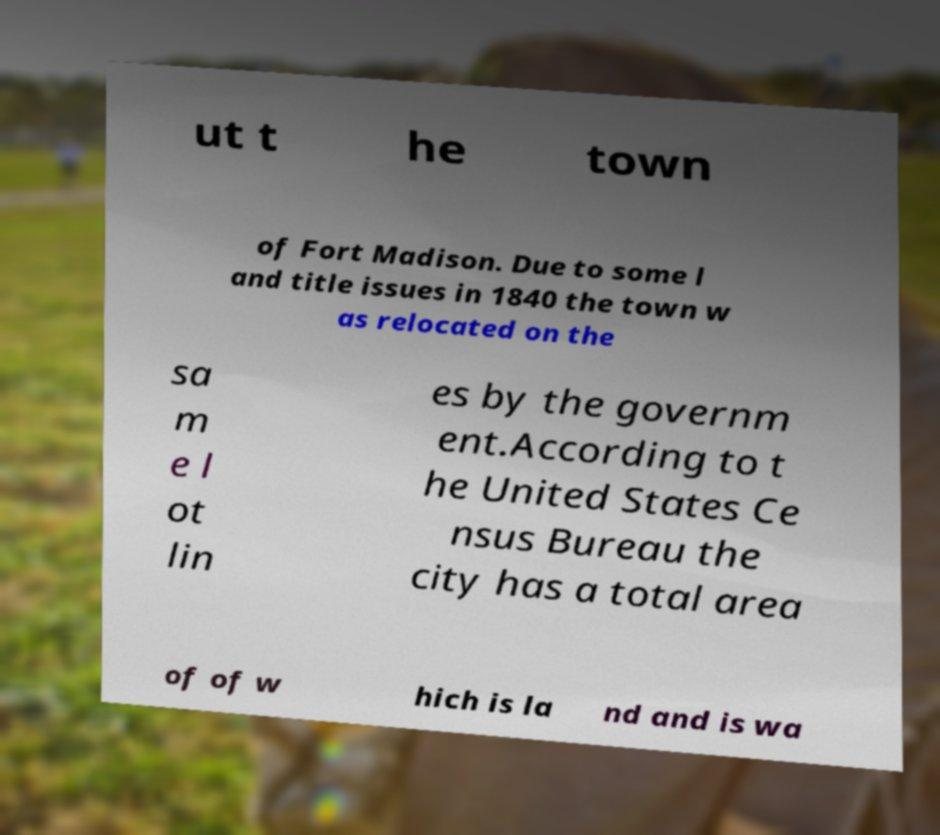There's text embedded in this image that I need extracted. Can you transcribe it verbatim? ut t he town of Fort Madison. Due to some l and title issues in 1840 the town w as relocated on the sa m e l ot lin es by the governm ent.According to t he United States Ce nsus Bureau the city has a total area of of w hich is la nd and is wa 